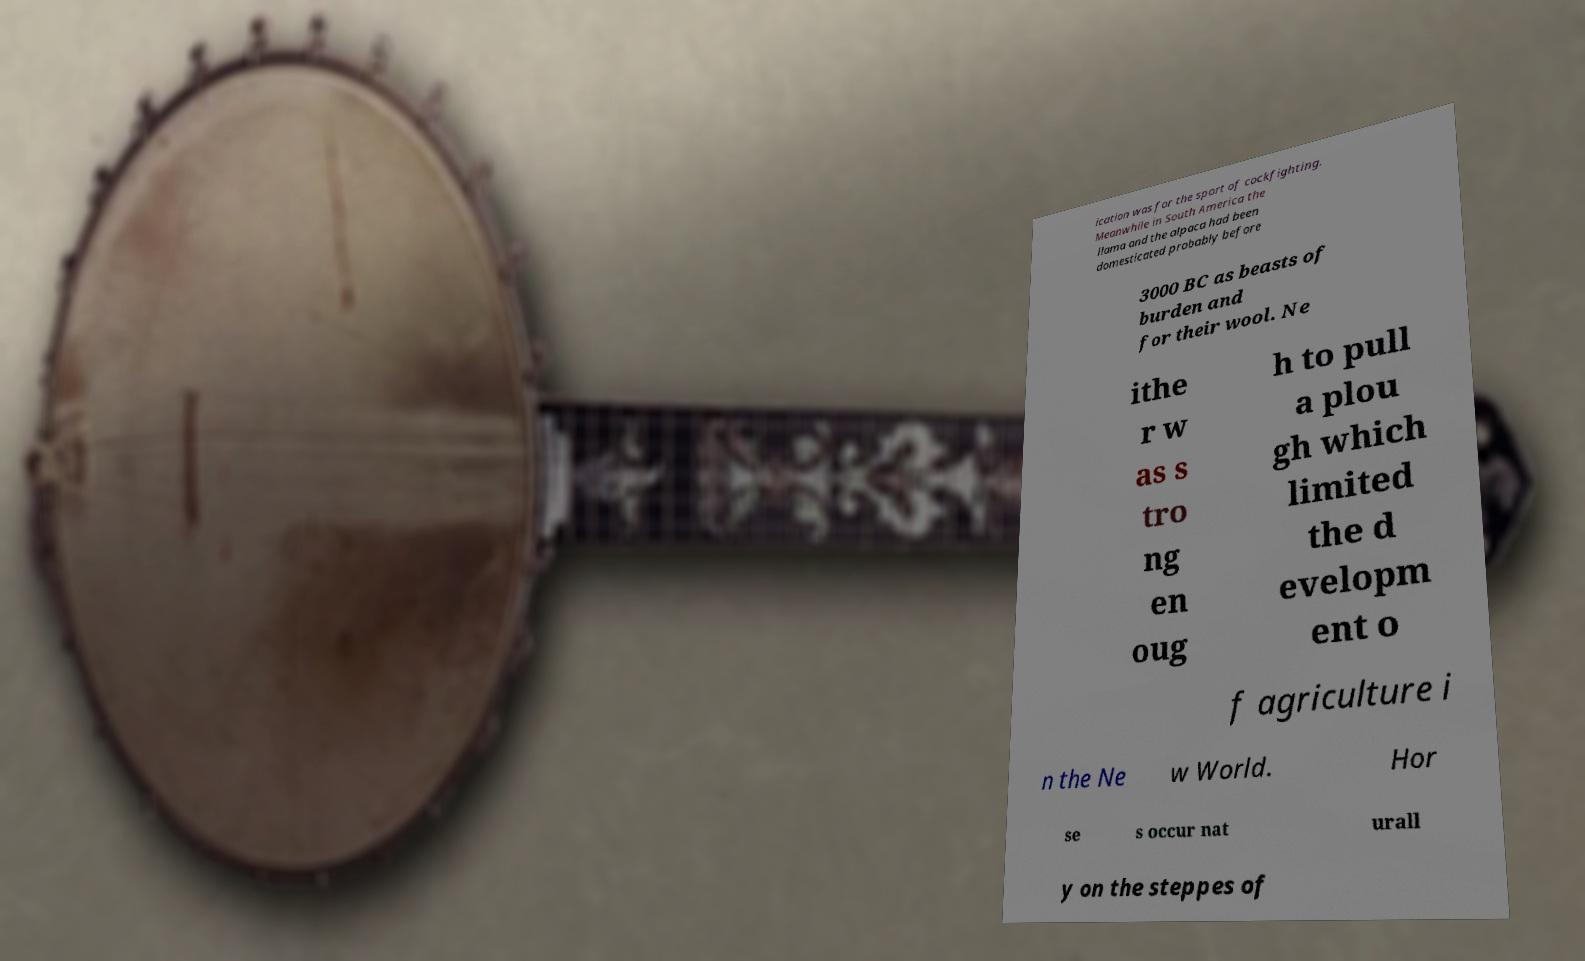Can you accurately transcribe the text from the provided image for me? ication was for the sport of cockfighting. Meanwhile in South America the llama and the alpaca had been domesticated probably before 3000 BC as beasts of burden and for their wool. Ne ithe r w as s tro ng en oug h to pull a plou gh which limited the d evelopm ent o f agriculture i n the Ne w World. Hor se s occur nat urall y on the steppes of 